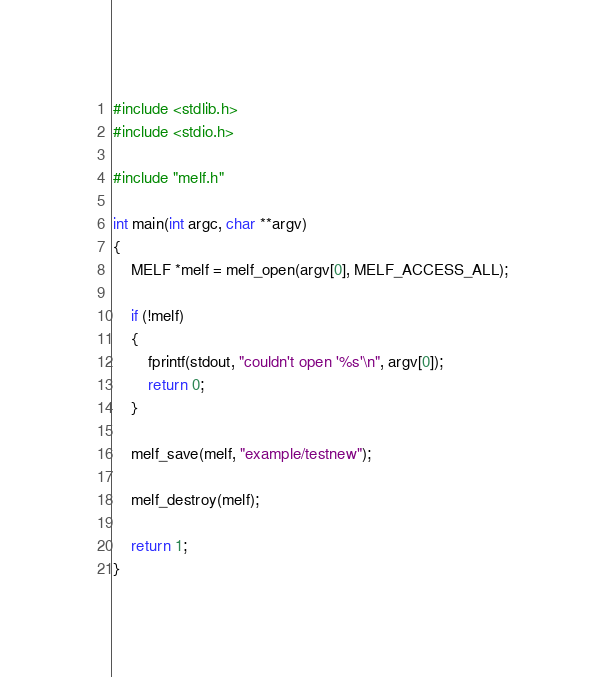Convert code to text. <code><loc_0><loc_0><loc_500><loc_500><_C_>#include <stdlib.h>
#include <stdio.h>

#include "melf.h"

int main(int argc, char **argv)
{
	MELF *melf = melf_open(argv[0], MELF_ACCESS_ALL);

	if (!melf)
	{
		fprintf(stdout, "couldn't open '%s'\n", argv[0]);
		return 0;
	}

	melf_save(melf, "example/testnew");

	melf_destroy(melf);

	return 1;
}
</code> 